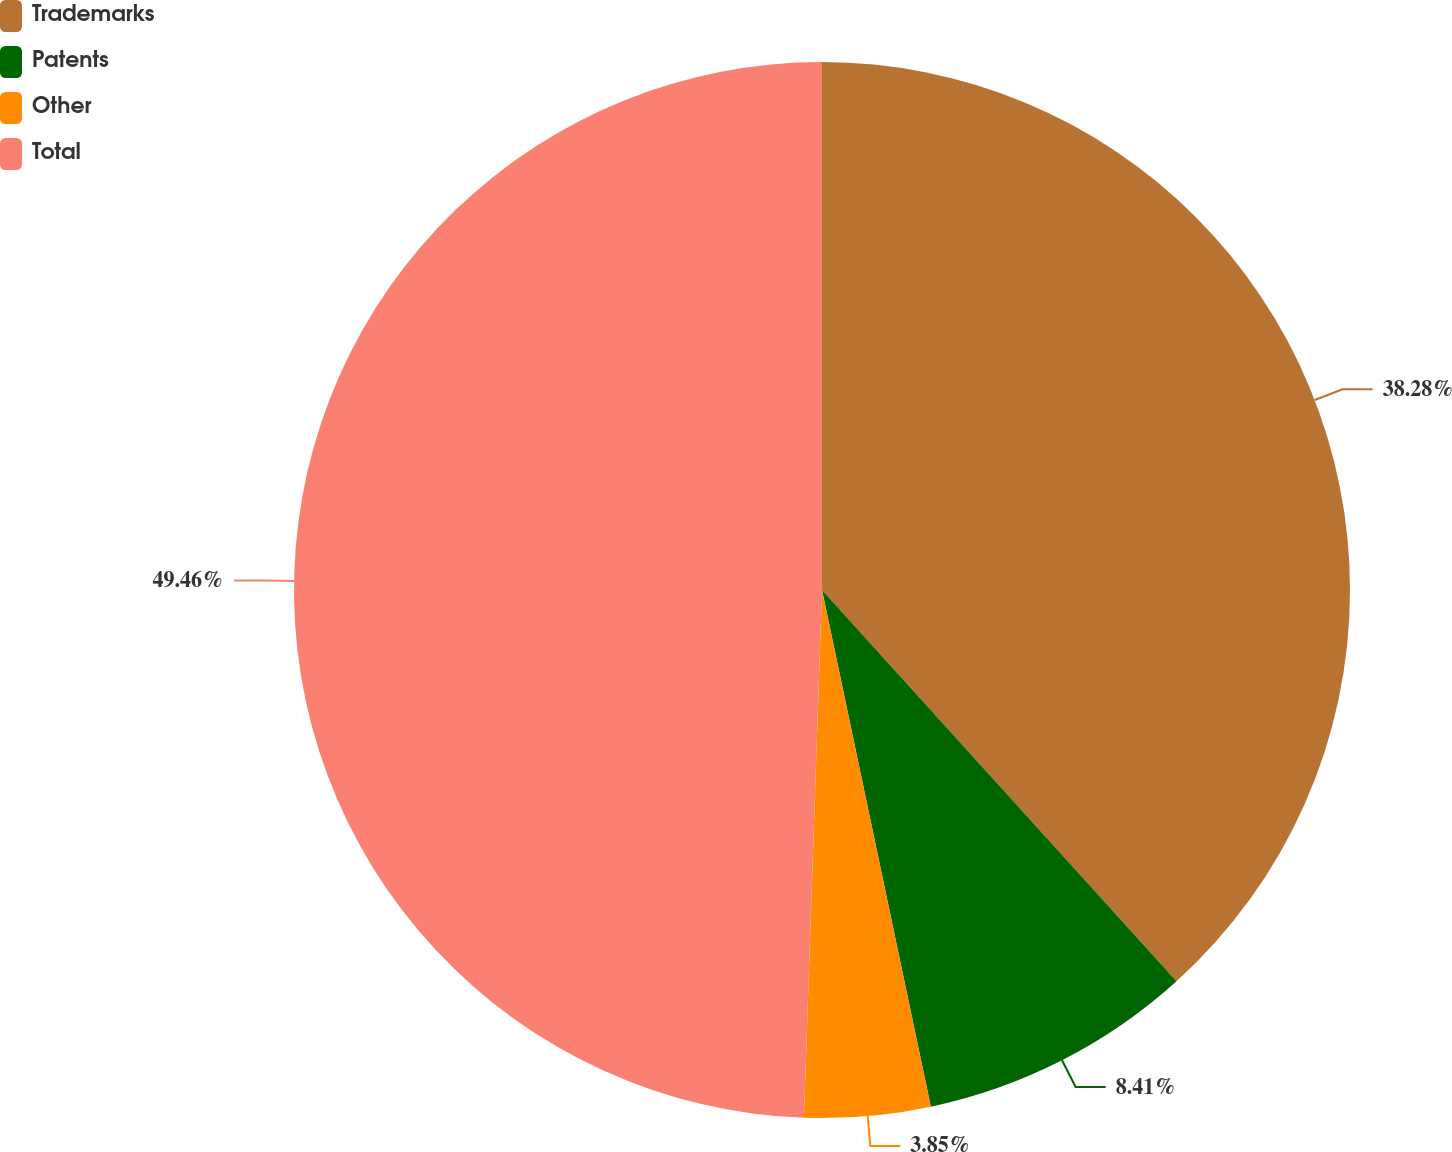<chart> <loc_0><loc_0><loc_500><loc_500><pie_chart><fcel>Trademarks<fcel>Patents<fcel>Other<fcel>Total<nl><fcel>38.28%<fcel>8.41%<fcel>3.85%<fcel>49.45%<nl></chart> 